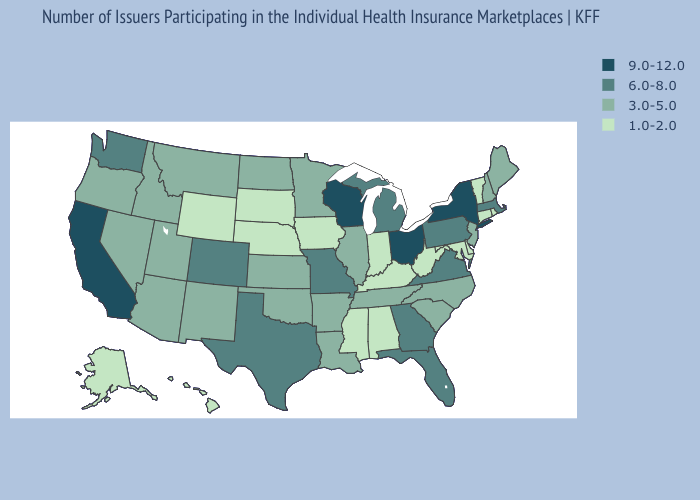What is the value of Tennessee?
Be succinct. 3.0-5.0. Does Kentucky have a lower value than South Dakota?
Give a very brief answer. No. Among the states that border Nevada , which have the lowest value?
Quick response, please. Arizona, Idaho, Oregon, Utah. What is the highest value in the USA?
Write a very short answer. 9.0-12.0. Among the states that border Utah , which have the lowest value?
Short answer required. Wyoming. How many symbols are there in the legend?
Short answer required. 4. Which states have the lowest value in the USA?
Keep it brief. Alabama, Alaska, Connecticut, Delaware, Hawaii, Indiana, Iowa, Kentucky, Maryland, Mississippi, Nebraska, Rhode Island, South Dakota, Vermont, West Virginia, Wyoming. Which states have the lowest value in the South?
Keep it brief. Alabama, Delaware, Kentucky, Maryland, Mississippi, West Virginia. Name the states that have a value in the range 1.0-2.0?
Keep it brief. Alabama, Alaska, Connecticut, Delaware, Hawaii, Indiana, Iowa, Kentucky, Maryland, Mississippi, Nebraska, Rhode Island, South Dakota, Vermont, West Virginia, Wyoming. What is the lowest value in the South?
Write a very short answer. 1.0-2.0. What is the highest value in states that border West Virginia?
Write a very short answer. 9.0-12.0. Does South Dakota have the highest value in the MidWest?
Short answer required. No. Among the states that border Kentucky , which have the highest value?
Answer briefly. Ohio. Does Maryland have a higher value than New Mexico?
Concise answer only. No. What is the value of New Hampshire?
Keep it brief. 3.0-5.0. 